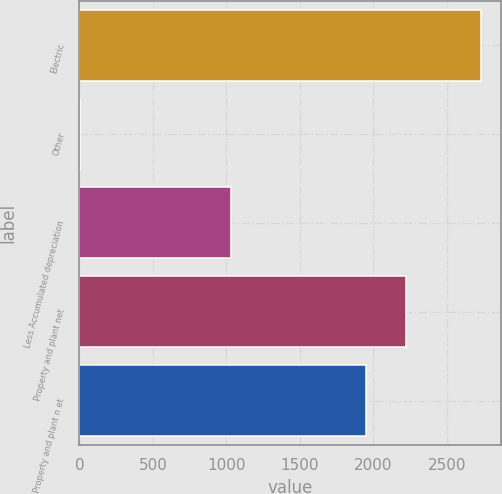Convert chart. <chart><loc_0><loc_0><loc_500><loc_500><bar_chart><fcel>Electric<fcel>Other<fcel>Less Accumulated depreciation<fcel>Property and plant net<fcel>Property and plant n et<nl><fcel>2730<fcel>6<fcel>1032<fcel>2222.4<fcel>1950<nl></chart> 